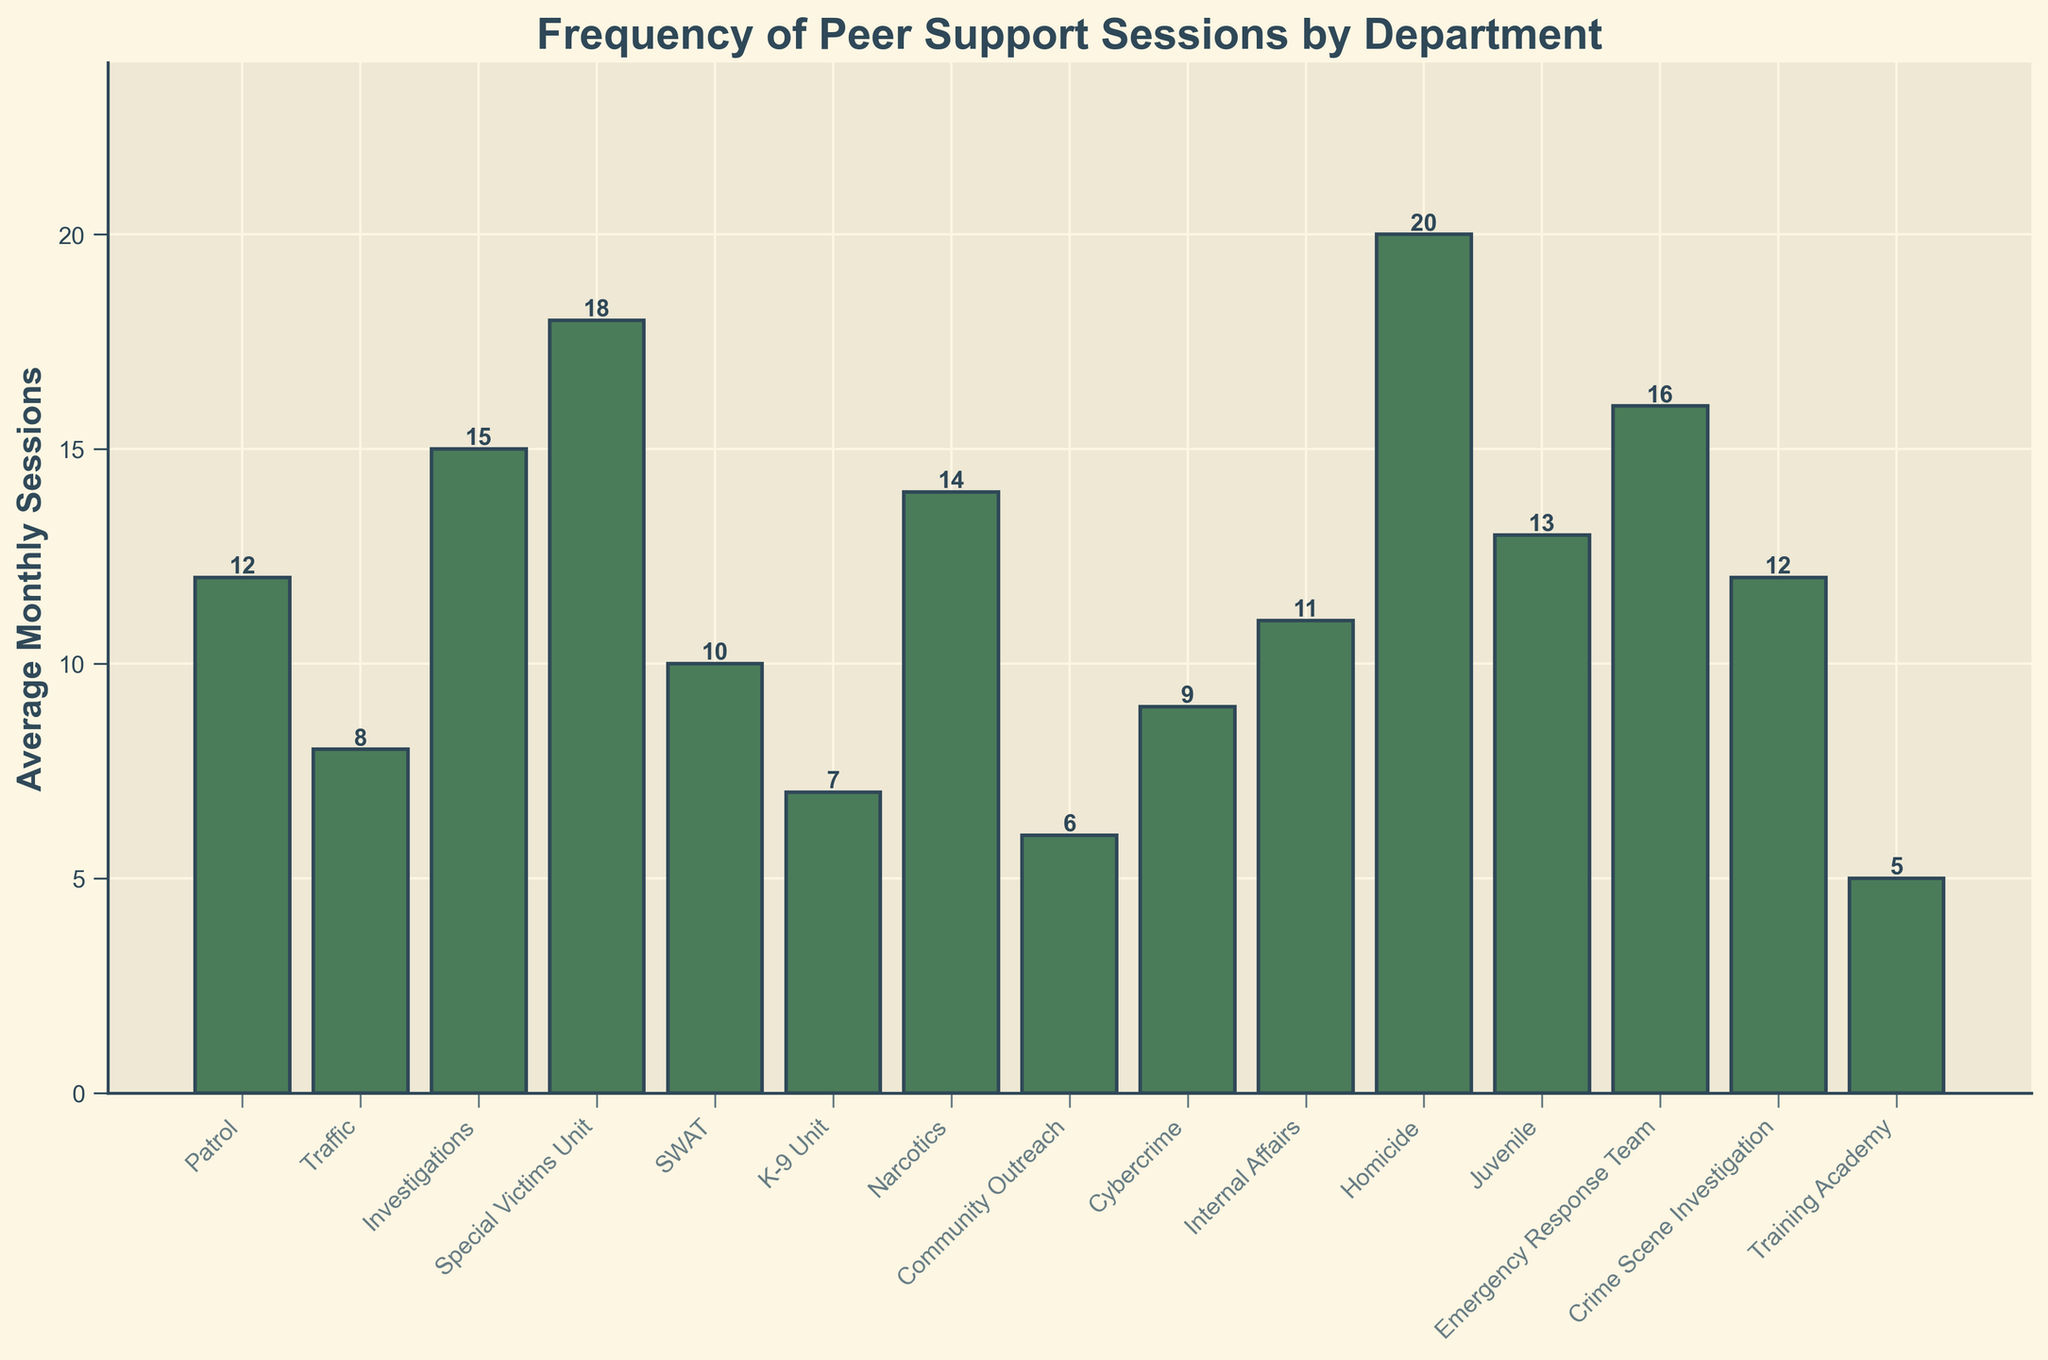Which department utilizes the peer support sessions most frequently? By looking for the tallest bar in the chart, we can identify that the department with the highest average monthly sessions is the Homicide department.
Answer: Homicide Which two departments have the closest number of peer support sessions on average? By comparing the heights of the bars, we see that the Patrol and Crime Scene Investigation departments both have 12 average monthly sessions, which is the same and thus the closest.
Answer: Patrol and Crime Scene Investigation How many more sessions does the Special Victims Unit have compared to the K-9 Unit? Special Victims Unit has 18 average monthly sessions while the K-9 Unit has 7. Subtracting these, 18 - 7 = 11.
Answer: 11 What is the average number of peer support sessions among all departments? Sum all the average monthly sessions: 12 + 8 + 15 + 18 + 10 + 7 + 14 + 6 + 9 + 11 + 20 + 13 + 16 + 12 + 5 = 176. Divide this by the number of departments (15). So, 176 / 15 ≈ 11.73.
Answer: 11.73 Which department has fewer average sessions than Internal Affairs but more than Cybercrime? Comparing the bars, Internal Affairs has 11 sessions and Cybercrime has 9. Departments with more than 9 but less than 11 sessions include the Traffic department with 8 sessions.
Answer: None How many departments have average sessions greater than the overall average? The overall average is approximately 11.73. Departments with values greater than this are Investigations (15), Special Victims Unit (18), Narcotics (14), Homicide (20), Juvenile (13), and Emergency Response Team (16), making a total of 6 departments.
Answer: 6 Is the number of sessions in Traffic greater than or equal to in K-9 Unit? The Traffic department has 8 sessions, while the K-9 Unit has 7 sessions. Since 8 is greater than 7, Traffic has more sessions.
Answer: Yes What is the total number of sessions for both the SWAT and Narcotics departments combined? Add the averages for SWAT (10) and Narcotics (14) to get 10 + 14 = 24.
Answer: 24 Which department has the second highest number of average monthly sessions? By checking the heights of the bars, Homicide has the highest (20), and Special Victims Unit is the second highest (18).
Answer: Special Victims Unit 